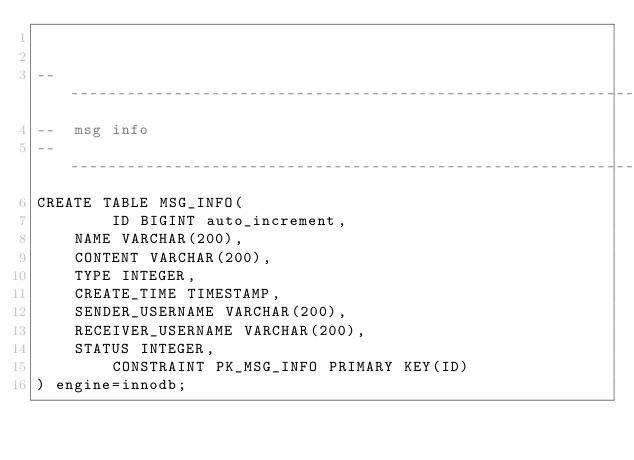Convert code to text. <code><loc_0><loc_0><loc_500><loc_500><_SQL_>

-------------------------------------------------------------------------------
--  msg info
-------------------------------------------------------------------------------
CREATE TABLE MSG_INFO(
        ID BIGINT auto_increment,
	NAME VARCHAR(200),
	CONTENT VARCHAR(200),
	TYPE INTEGER,
	CREATE_TIME TIMESTAMP,
	SENDER_USERNAME VARCHAR(200),
	RECEIVER_USERNAME VARCHAR(200),
	STATUS INTEGER,
        CONSTRAINT PK_MSG_INFO PRIMARY KEY(ID)
) engine=innodb;

</code> 